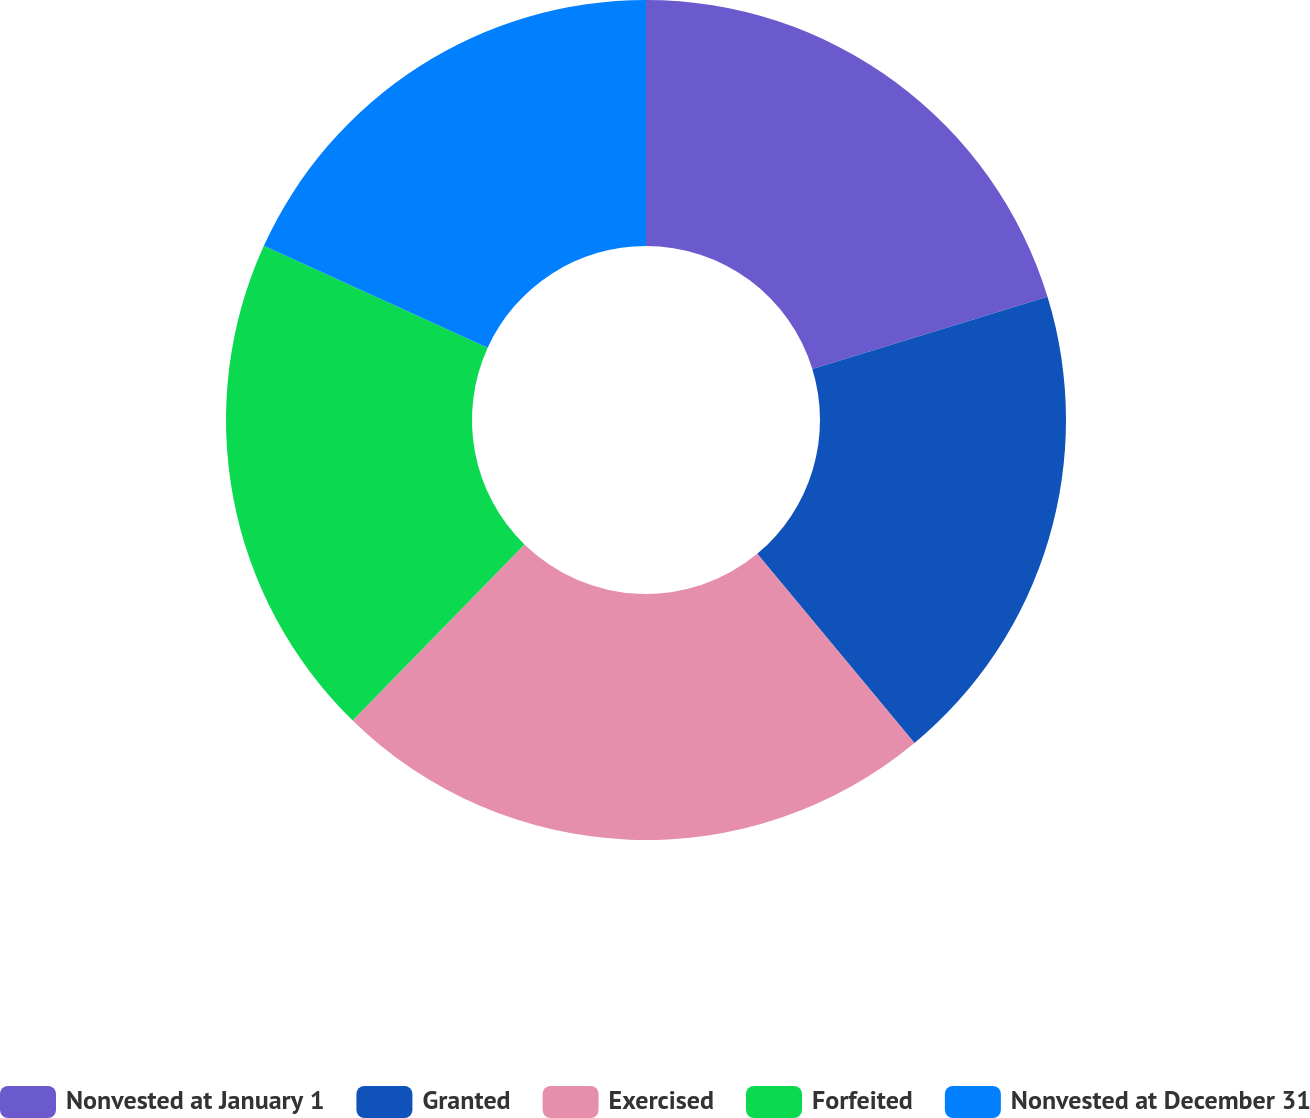Convert chart to OTSL. <chart><loc_0><loc_0><loc_500><loc_500><pie_chart><fcel>Nonvested at January 1<fcel>Granted<fcel>Exercised<fcel>Forfeited<fcel>Nonvested at December 31<nl><fcel>20.26%<fcel>18.7%<fcel>23.34%<fcel>19.5%<fcel>18.19%<nl></chart> 